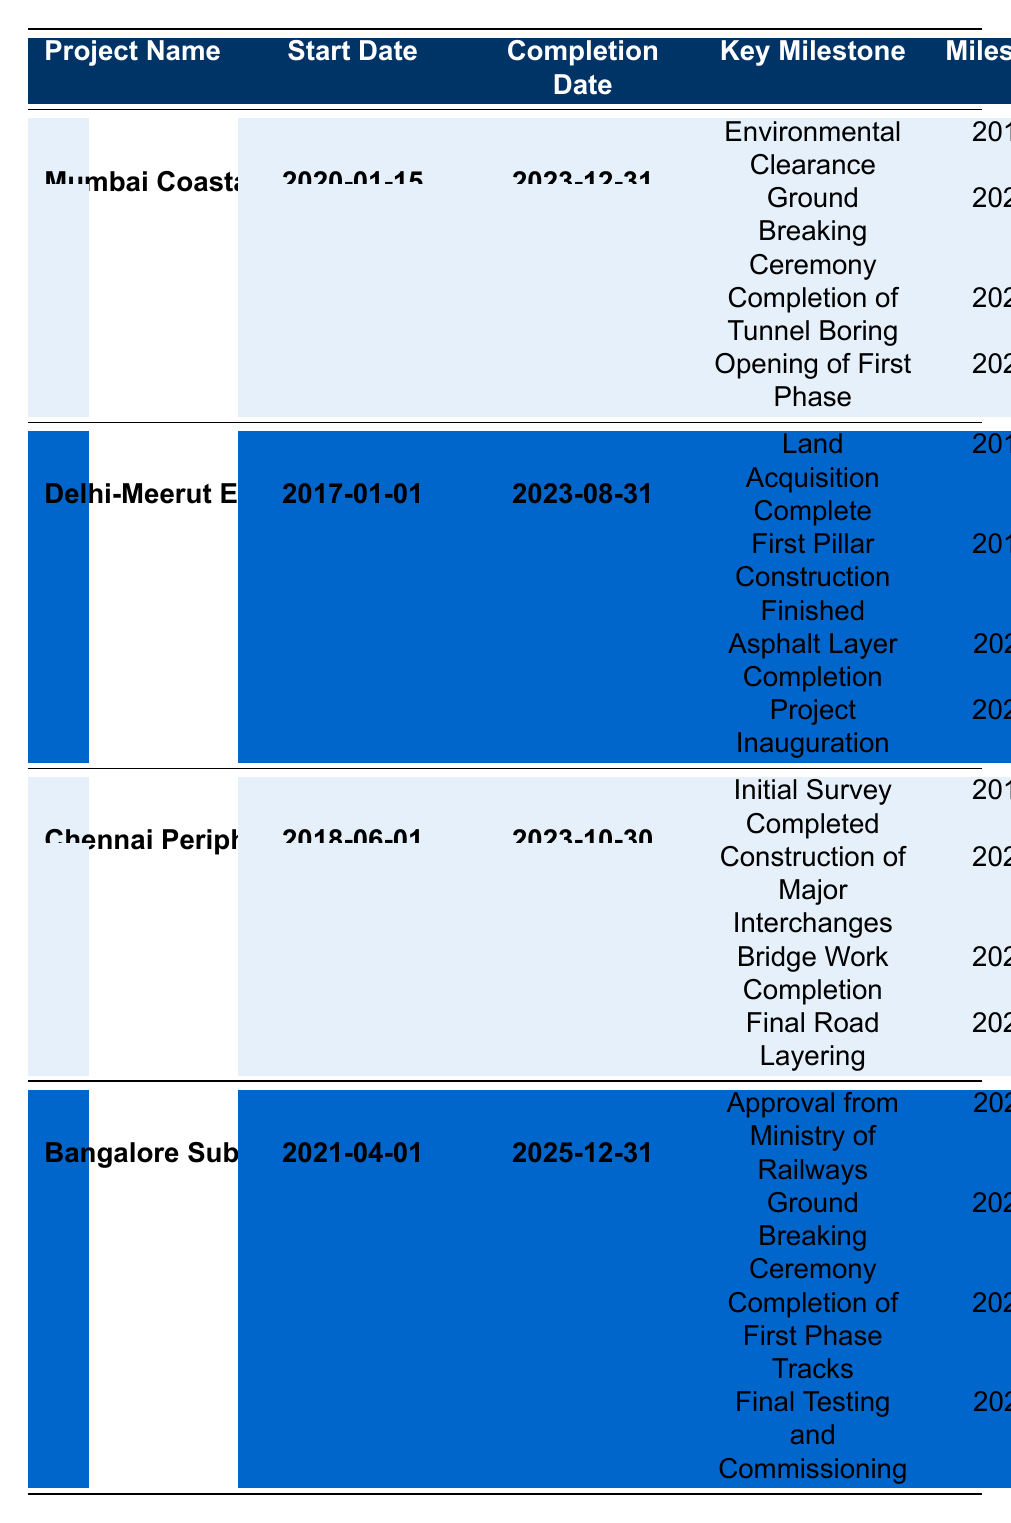What is the start date of the Mumbai Coastal Road Project? The table lists the start date for the Mumbai Coastal Road Project as 2020-01-15.
Answer: 2020-01-15 When is the projected completion date for the Chennai Peripheral Ring Road? According to the table, the completion date for the Chennai Peripheral Ring Road is 2023-10-30.
Answer: 2023-10-30 How many key milestones are listed for the Bangalore Suburban Rail Project? The table shows 4 milestones under the Bangalore Suburban Rail Project.
Answer: 4 What is the date for the 'Opening of First Phase' milestone in the Mumbai Coastal Road Project? In the table, the date for the 'Opening of First Phase' milestone is listed as 2023-06-30.
Answer: 2023-06-30 Is the 'Final Testing and Commissioning' milestone before or after the completion date of the Bangalore Suburban Rail Project? The completion date for the Bangalore Suburban Rail Project is 2025-12-31, and the 'Final Testing and Commissioning' milestone is on 2025-11-30, which is before the completion date.
Answer: Before What is the difference in years between the start date of the Delhi-Meerut Expressway and the completion date of the Chennai Peripheral Ring Road? The Delhi-Meerut Expressway starts on 2017-01-01 and completes on 2023-10-30. To find the difference in years: 2023 - 2017 = 6 years.
Answer: 6 years Which project had the earliest 'Ground Breaking Ceremony' based on the table? The table lists the Ground Breaking Ceremony for the Delhi-Meerut Expressway on 2019-10-15 and for the Mumbai Coastal Road Project on 2020-01-15. The earliest is the Delhi-Meerut Expressway.
Answer: Delhi-Meerut Expressway What is the average duration (in months) for the completion of projects starting from their respective start dates until completion? Calculate the duration for each project: Mumbai Coastal Road (36 months), Delhi-Meerut Expressway (78 months), Chennai Peripheral Ring Road (65 months), and Bangalore Suburban Rail Project (57 months). Sum: 36 + 78 + 65 + 57 = 236 months. Average: 236/4 = 59 months.
Answer: 59 months Is there any milestone for the Chennai Peripheral Ring Road that was completed after its start date? Milestones such as 'Construction of Major Interchanges' (2020-03-20) and 'Bridge Work Completion' (2022-08-10) were completed after the project started on 2018-06-01, so yes, there are milestones completed after the start date.
Answer: Yes What is the latest milestone date for the Delhi-Meerut Expressway project? The table shows the latest milestone date for the Delhi-Meerut Expressway is 2023-09-01, which is the date for 'Project Inauguration.'
Answer: 2023-09-01 How many of the listed projects are projected to be completed in 2023? The table shows three projects (Mumbai Coastal Road Project, Delhi-Meerut Expressway, Chennai Peripheral Ring Road) are set to complete in 2023.
Answer: 3 